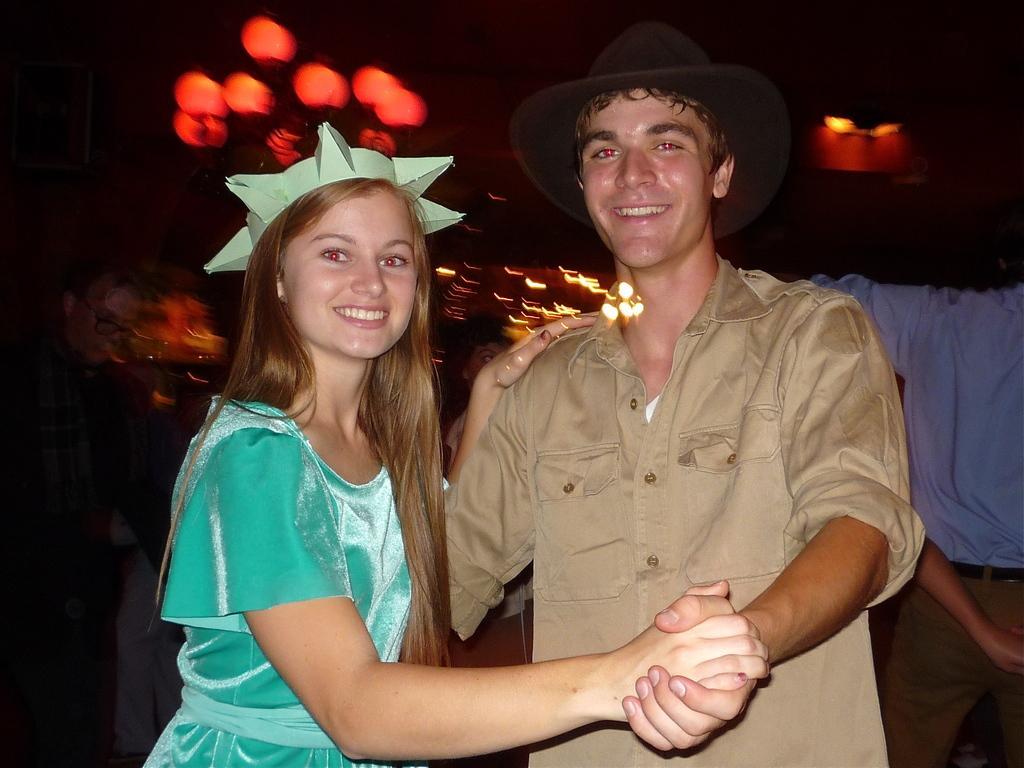How would you summarize this image in a sentence or two? In the center of the image we can see man and woman standing. In the background we can see lights, person, cloth and wall. 